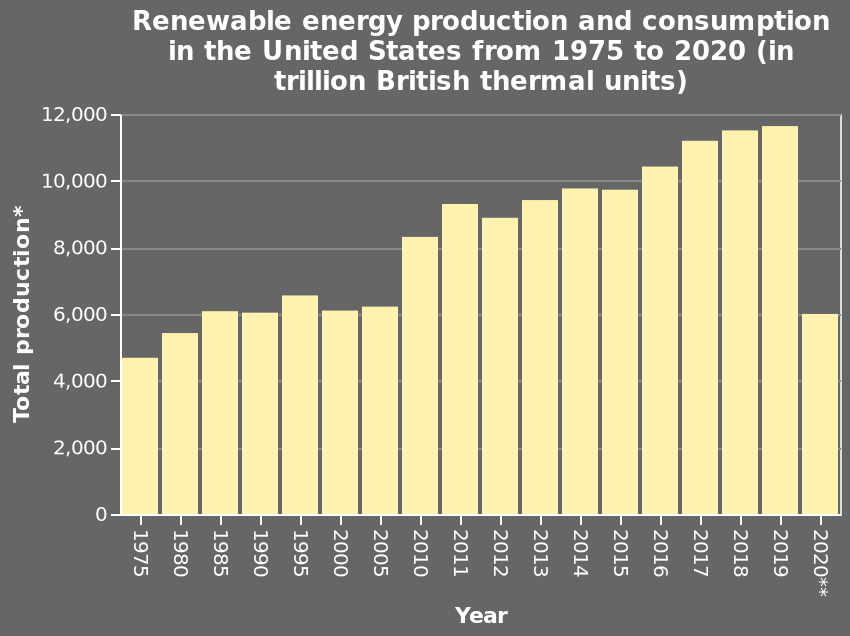<image>
What does the x-axis represent in the bar diagram? The x-axis represents the years from 1975 to 2020. What does the bar diagram illustrate? The bar diagram illustrates the production and consumption of renewable energy in the United States over a span of 45 years. The data is represented in trillion British thermal units. Has the production of renewable energy been consistent over the years? No, the production of renewable energy has shown an increasing trend, except in 2020 when it dropped to year 2000 levels. 